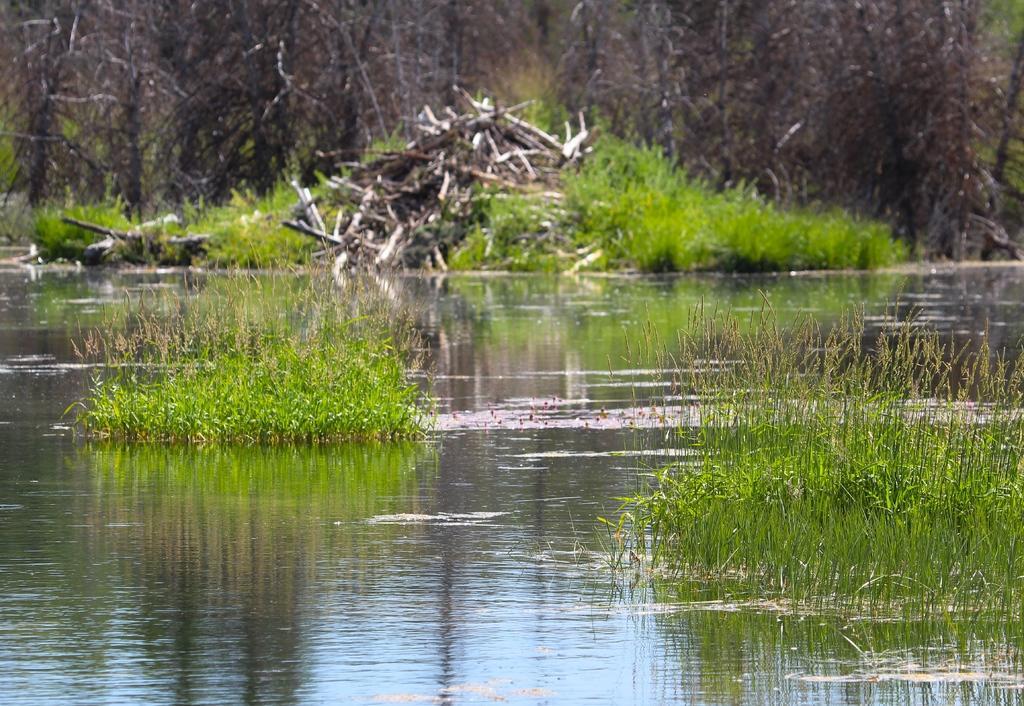Please provide a concise description of this image. In this image I can see the grass in the water and the grass is in green color. In the background I can see few dried trees. 